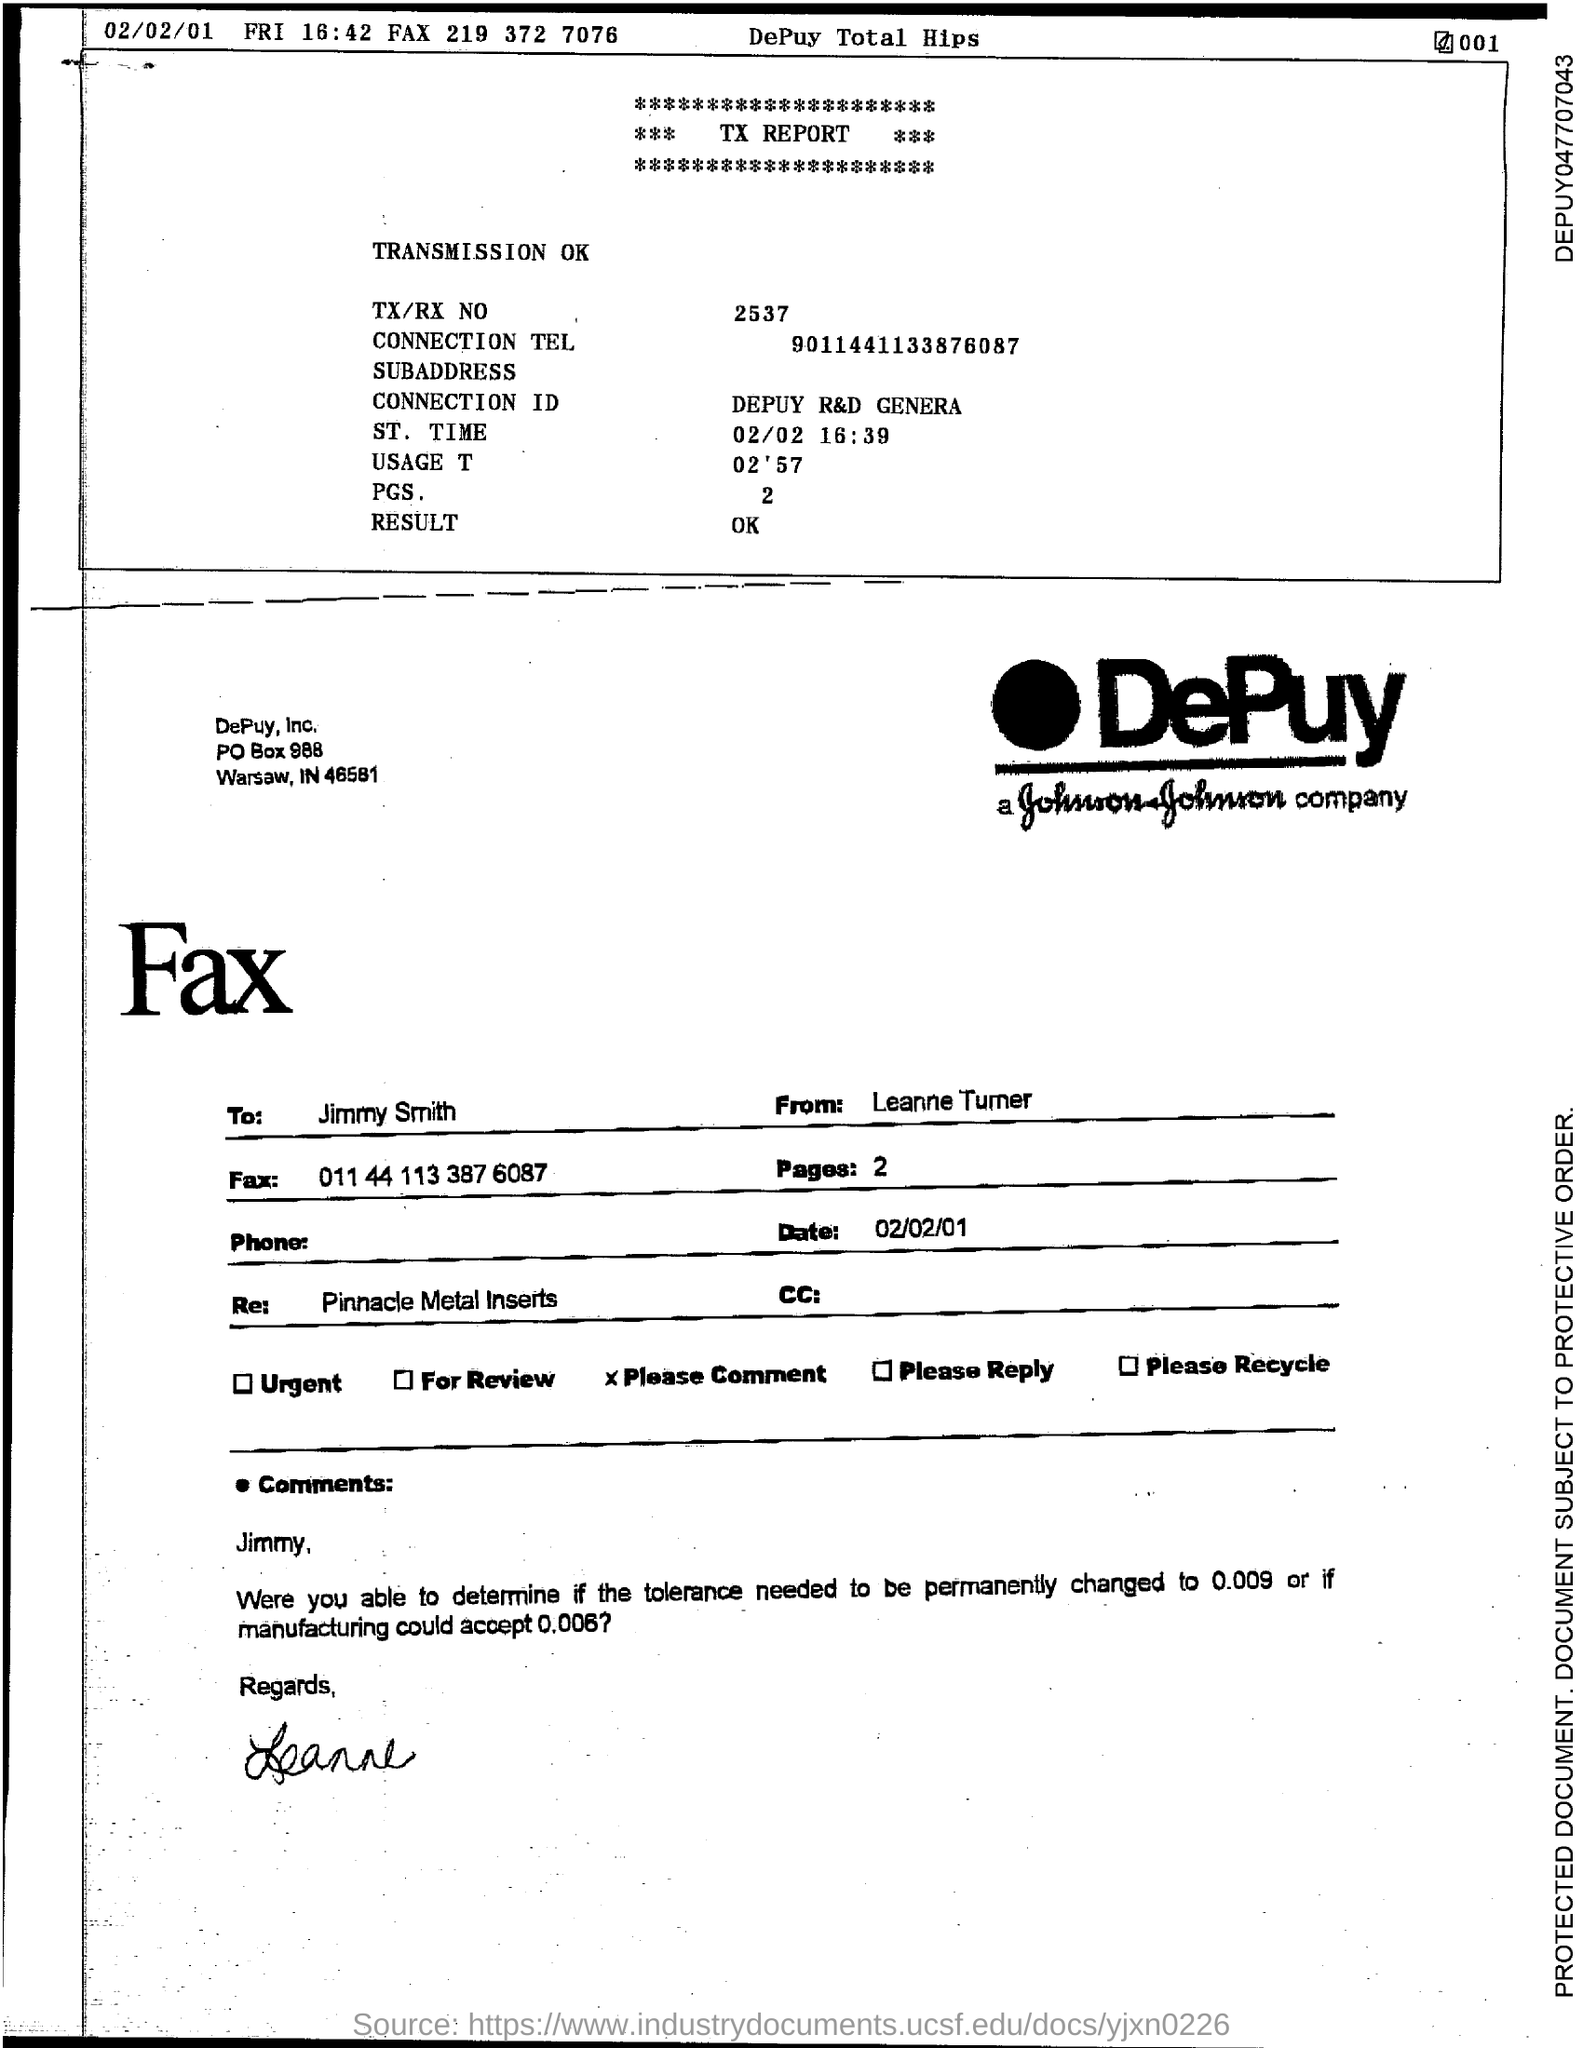What is the TX/RX No.?
Give a very brief answer. 2537. What is the Connection Tel.?
Your response must be concise. 9011441133876087. What is the Connection ID?
Your answer should be compact. Depuy R&D Genera. What is the St. Time?
Offer a terse response. 02/02 16:39. What is the Usage T?
Ensure brevity in your answer.  02'57. What is the PGS?
Keep it short and to the point. 2. What is the Result?
Offer a very short reply. OK. To Whom is this Fax addressed to?
Provide a short and direct response. Jimmy. Who is this Fax from?
Make the answer very short. Leanne Turner. 